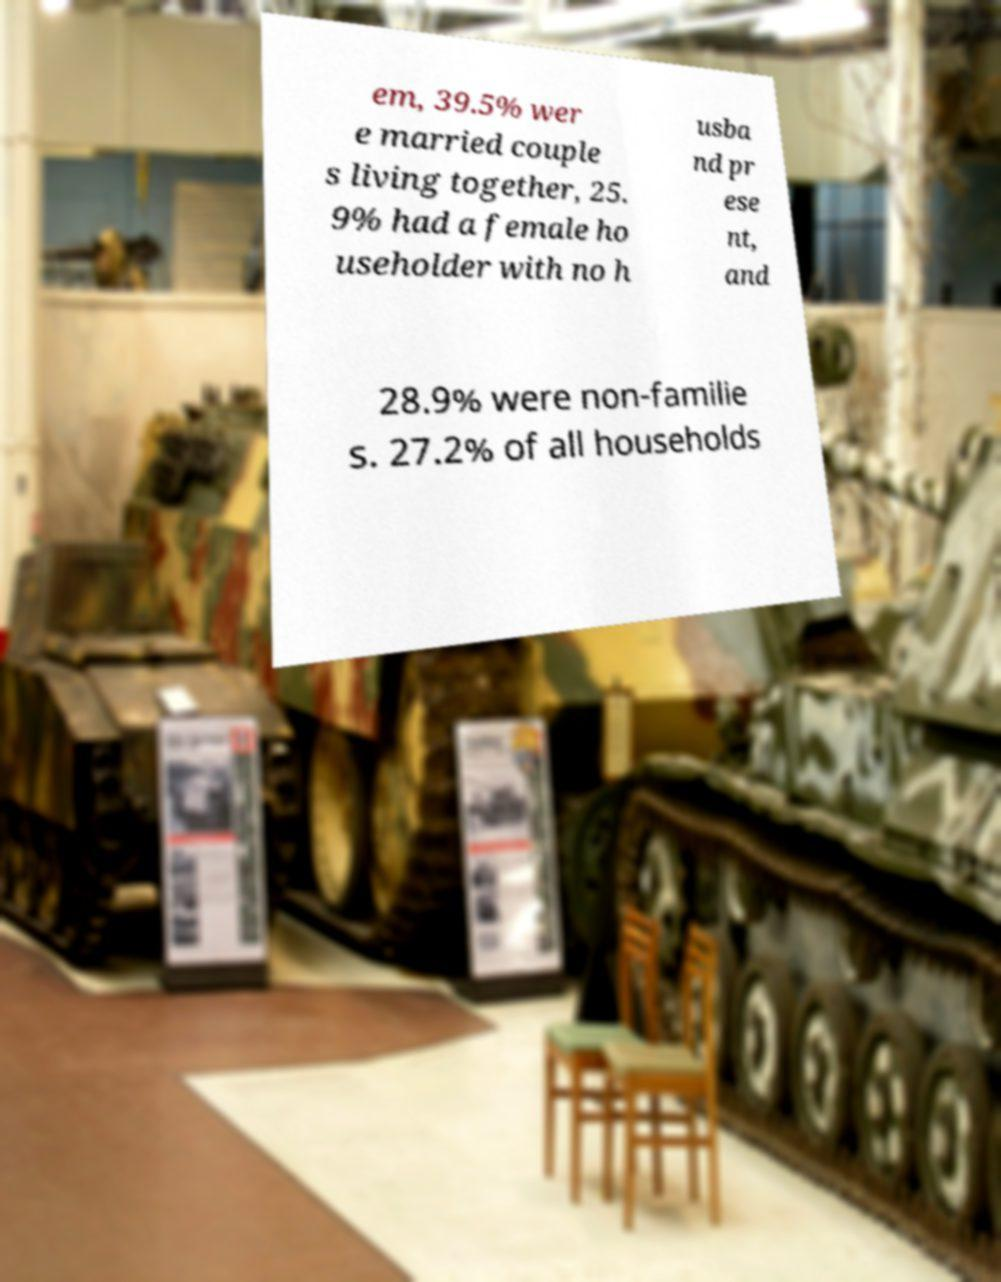Could you assist in decoding the text presented in this image and type it out clearly? em, 39.5% wer e married couple s living together, 25. 9% had a female ho useholder with no h usba nd pr ese nt, and 28.9% were non-familie s. 27.2% of all households 